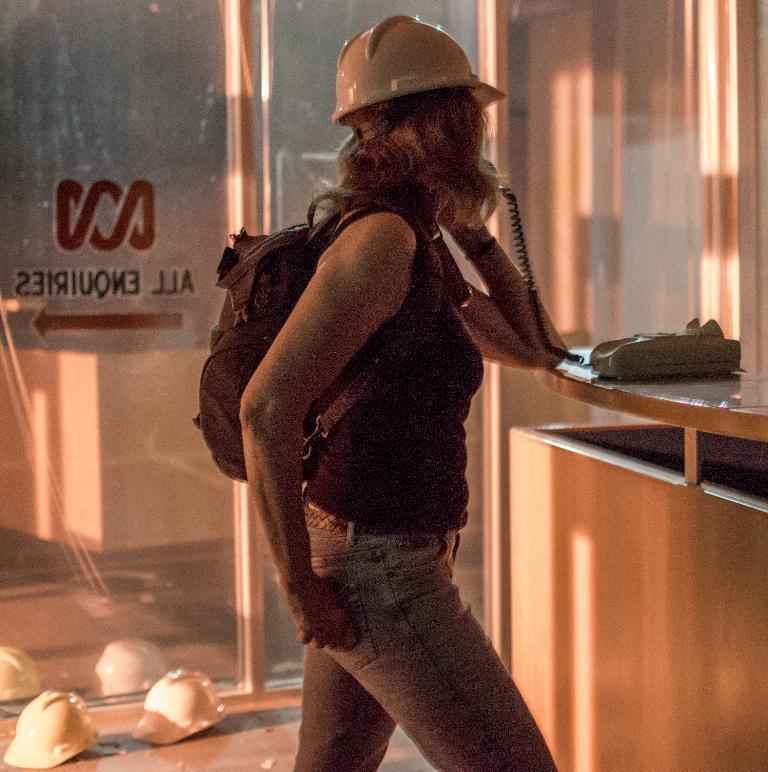How would you summarize this image in a sentence or two? In this image we can see a woman is standing. She is wearing a top, jeans, carrying bad and holding telephone. In front of her, we can see a table and a telephone. In the background, we can see glass wall. We can see two white color helmets on the floor. The woman is also wearing a white color helmet. 